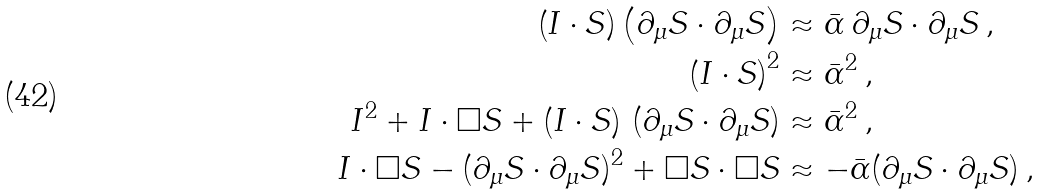<formula> <loc_0><loc_0><loc_500><loc_500>\left ( I \cdot S \right ) \left ( \partial _ { \mu } S \cdot \partial _ { \mu } S \right ) & \approx \bar { \alpha } \, \partial _ { \mu } S \cdot \partial _ { \mu } S \, , \\ \left ( I \cdot S \right ) ^ { 2 } & \approx \bar { \alpha } ^ { 2 } \, , \\ I ^ { 2 } + I \cdot \square S + \left ( I \cdot S \right ) \, ( \partial _ { \mu } S \cdot \partial _ { \mu } S ) & \approx \bar { \alpha } ^ { 2 } \, , \\ I \cdot \square S - ( \partial _ { \mu } S \cdot \partial _ { \mu } S ) ^ { 2 } + \square S \cdot \square S & \approx - \bar { \alpha } ( \partial _ { \mu } S \cdot \partial _ { \mu } S ) \, ,</formula> 